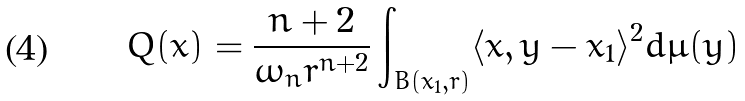Convert formula to latex. <formula><loc_0><loc_0><loc_500><loc_500>Q ( x ) = \frac { n + 2 } { \omega _ { n } r ^ { n + 2 } } \int _ { B ( x _ { 1 } , r ) } \langle x , y - x _ { 1 } \rangle ^ { 2 } d \mu ( y )</formula> 